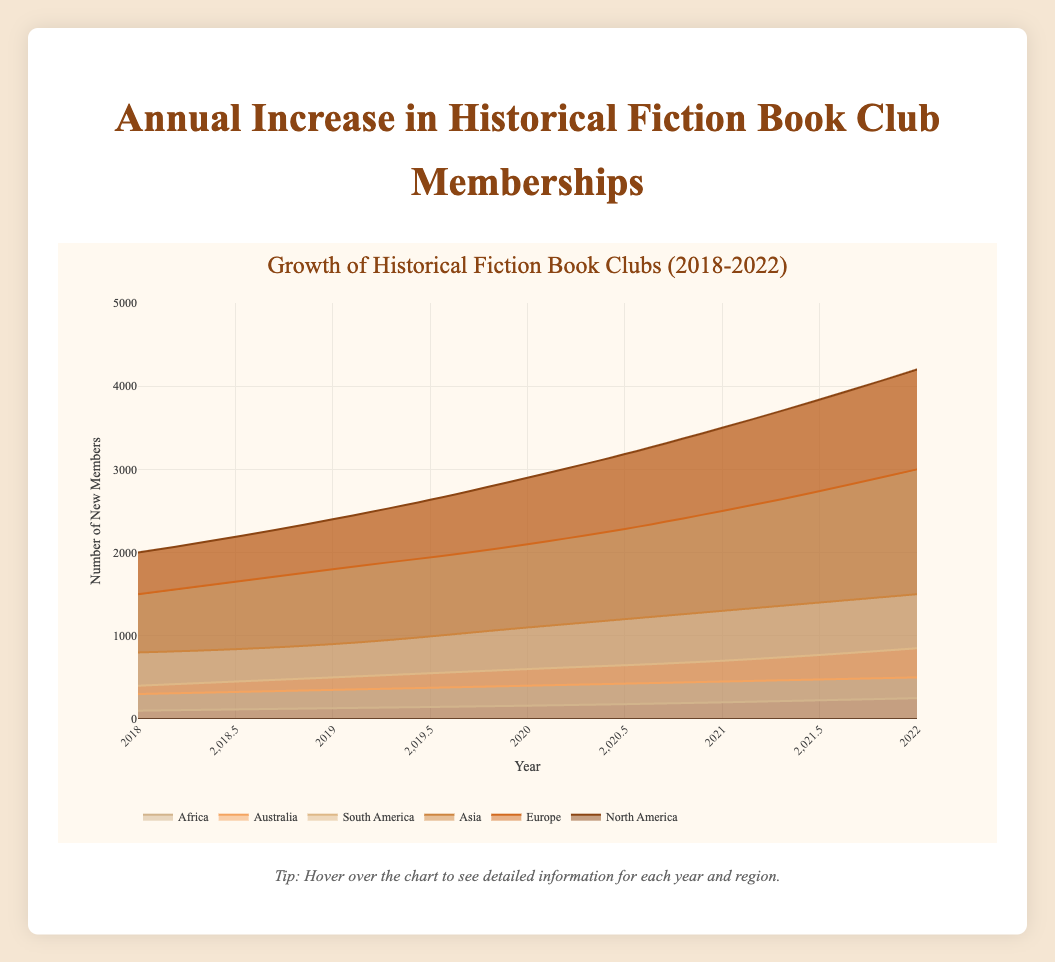Which region had the highest increase in book club memberships from 2018 to 2022? To determine which region had the highest increase, look at the values for 2018 and 2022 and calculate the difference. North America: 4200 - 2000 = 2200, Europe: 3000 - 1500 = 1500, Asia: 1500 - 800 = 700, South America: 850 - 400 = 450, Australia: 500 - 300 = 200, Africa: 250 - 100 = 150. North America had the highest increase.
Answer: North America How many total new memberships were there in Africa over the entire period? To find the total new memberships in Africa from 2018 to 2022, sum the values for each year: 100 + 130 + 160 + 200 + 250 = 840.
Answer: 840 Which two regions showed the smallest increase in memberships between 2018 and 2022? Calculate the difference in memberships from 2018 to 2022 for each region: North America: 2200, Europe: 1500, Asia: 700, South America: 450, Australia: 200, Africa: 150. The two smallest increases are for Australia and Africa.
Answer: Australia and Africa In which year did Asia experience the highest absolute increase in memberships compared to the previous year? Calculate the yearly increase for Asia: 2019: 100 (900-800), 2020: 200 (1100-900), 2021: 200 (1300-1100), 2022: 200 (1500-1300). Asia saw the highest increase of 200 members each year from 2019 to 2022, but since the question asks for an absolute increase and 2019 is the first year that matches, 2019 is chosen.
Answer: 2019 Which year had the smallest increase in total memberships across all regions? Calculate the total increase in memberships for each year: 2019: 2400 - 2000 + 1800 - 1500 + 900 - 800 + 500 - 400 + 350 - 300 + 130 - 100 = 830, 2020: 2900 - 2400 + 2100 - 1800 + 1100 - 900 + 600 - 500 + 400 - 350 + 160 - 130 = 830, 2021: 3500 - 2900 + 2500 - 2100 + 1300 - 1100 + 700 - 600 + 450 - 400 + 200 - 160 = 850, 2022: 4200 - 3500 + 3000 - 2500 + 1500 - 1300 + 850 - 700 + 500 - 450 + 250 - 200 = 900. 2019 and 2020 had the smallest increase of 830.
Answer: 2019 and 2020 Did South America or Australia see a higher growth in memberships from 2018 to 2022? Calculate the increase in memberships for both regions from 2018 to 2022: South America: 850 - 400 = 450, Australia: 500 - 300 = 200. South America saw a higher growth.
Answer: South America Between which years did North America see the highest annual increase in memberships? Calculate the annual increase in memberships for North America: 2019: 2400 - 2000 = 400, 2020: 2900 - 2400 = 500, 2021: 3500 - 2900 = 600, 2022: 4200 - 3500 = 700. The highest annual increase was between 2021 and 2022.
Answer: 2021 and 2022 By how much did Europe's membership increase from 2019 to 2020? Calculate the membership increase for Europe between 2019 and 2020: 2100 - 1800 = 300.
Answer: 300 